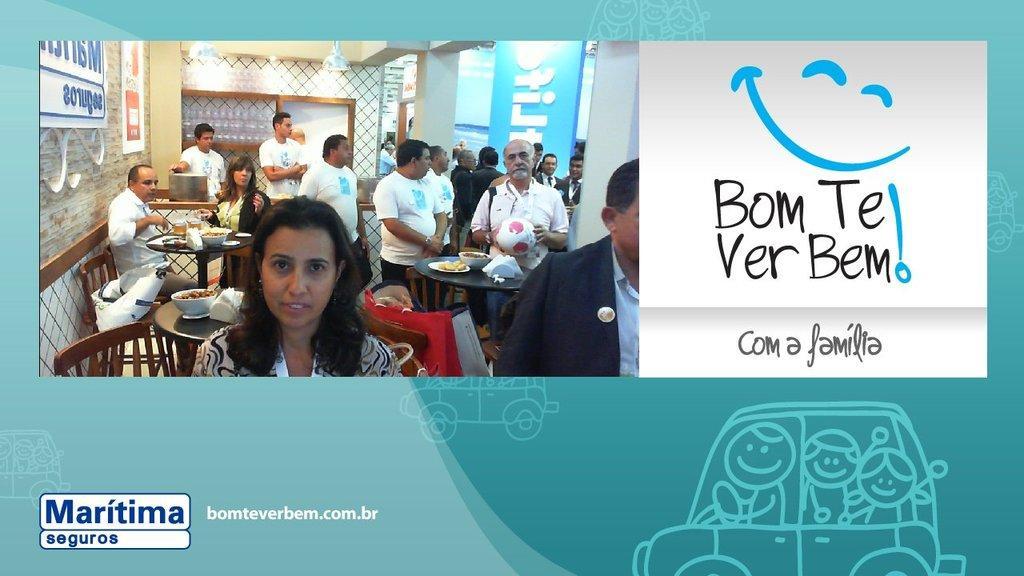How would you summarize this image in a sentence or two? In this image we can see there are few people some are sitting and some are standing in front of the table. On the tables there are some food items. In the background there is a wall and there is some text on the image. 